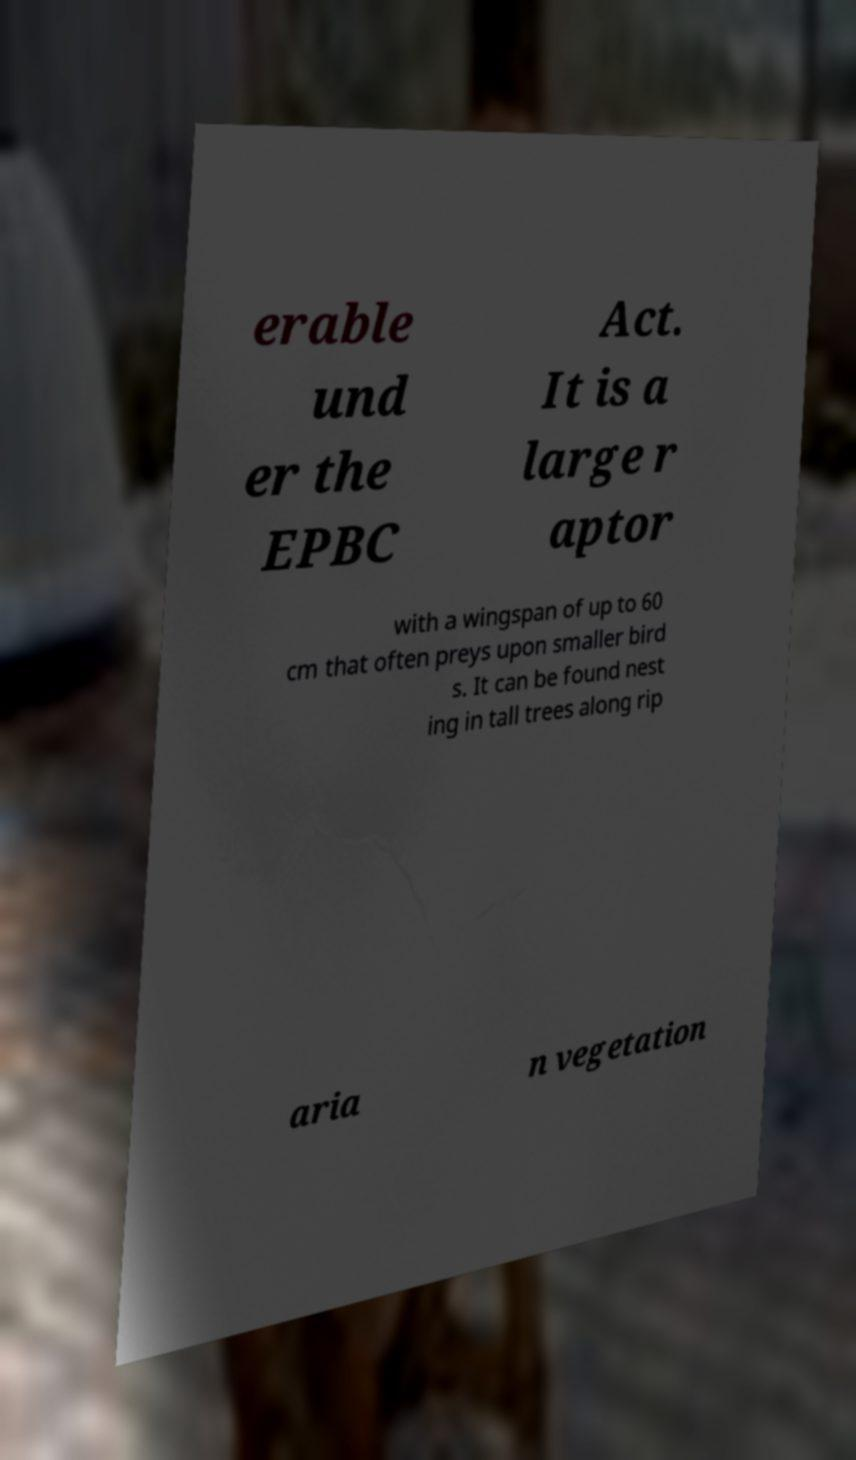Can you read and provide the text displayed in the image?This photo seems to have some interesting text. Can you extract and type it out for me? erable und er the EPBC Act. It is a large r aptor with a wingspan of up to 60 cm that often preys upon smaller bird s. It can be found nest ing in tall trees along rip aria n vegetation 